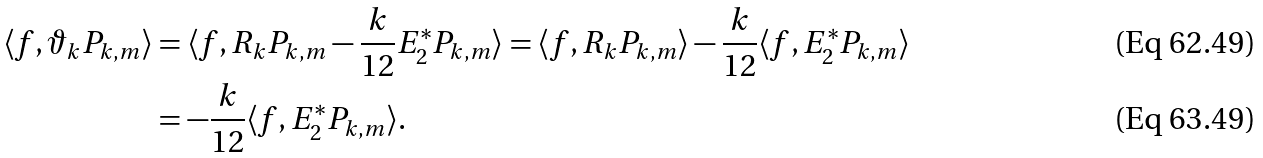<formula> <loc_0><loc_0><loc_500><loc_500>\langle f , \vartheta _ { k } P _ { k , m } \rangle & = \langle f , R _ { k } P _ { k , m } - \frac { k } { 1 2 } E _ { 2 } ^ { * } P _ { k , m } \rangle = \langle f , R _ { k } P _ { k , m } \rangle - \frac { k } { 1 2 } \langle f , E _ { 2 } ^ { * } P _ { k , m } \rangle \\ & = - \frac { k } { 1 2 } \langle f , E _ { 2 } ^ { * } P _ { k , m } \rangle .</formula> 